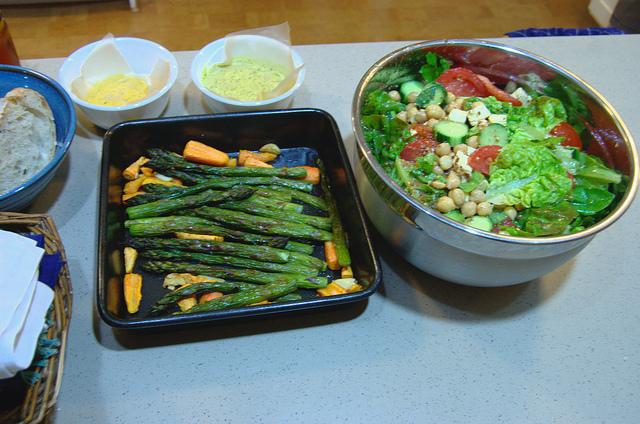Is this a healthy meal?
Short answer required. Yes. What type of green vegetable is being served?
Write a very short answer. Asparagus. What type of vegetable in the square pan?
Quick response, please. Asparagus. What color of the serving dishes?
Short answer required. Silver. How many bowls are in this picture?
Concise answer only. 4. Is the food tasty?
Quick response, please. Yes. 